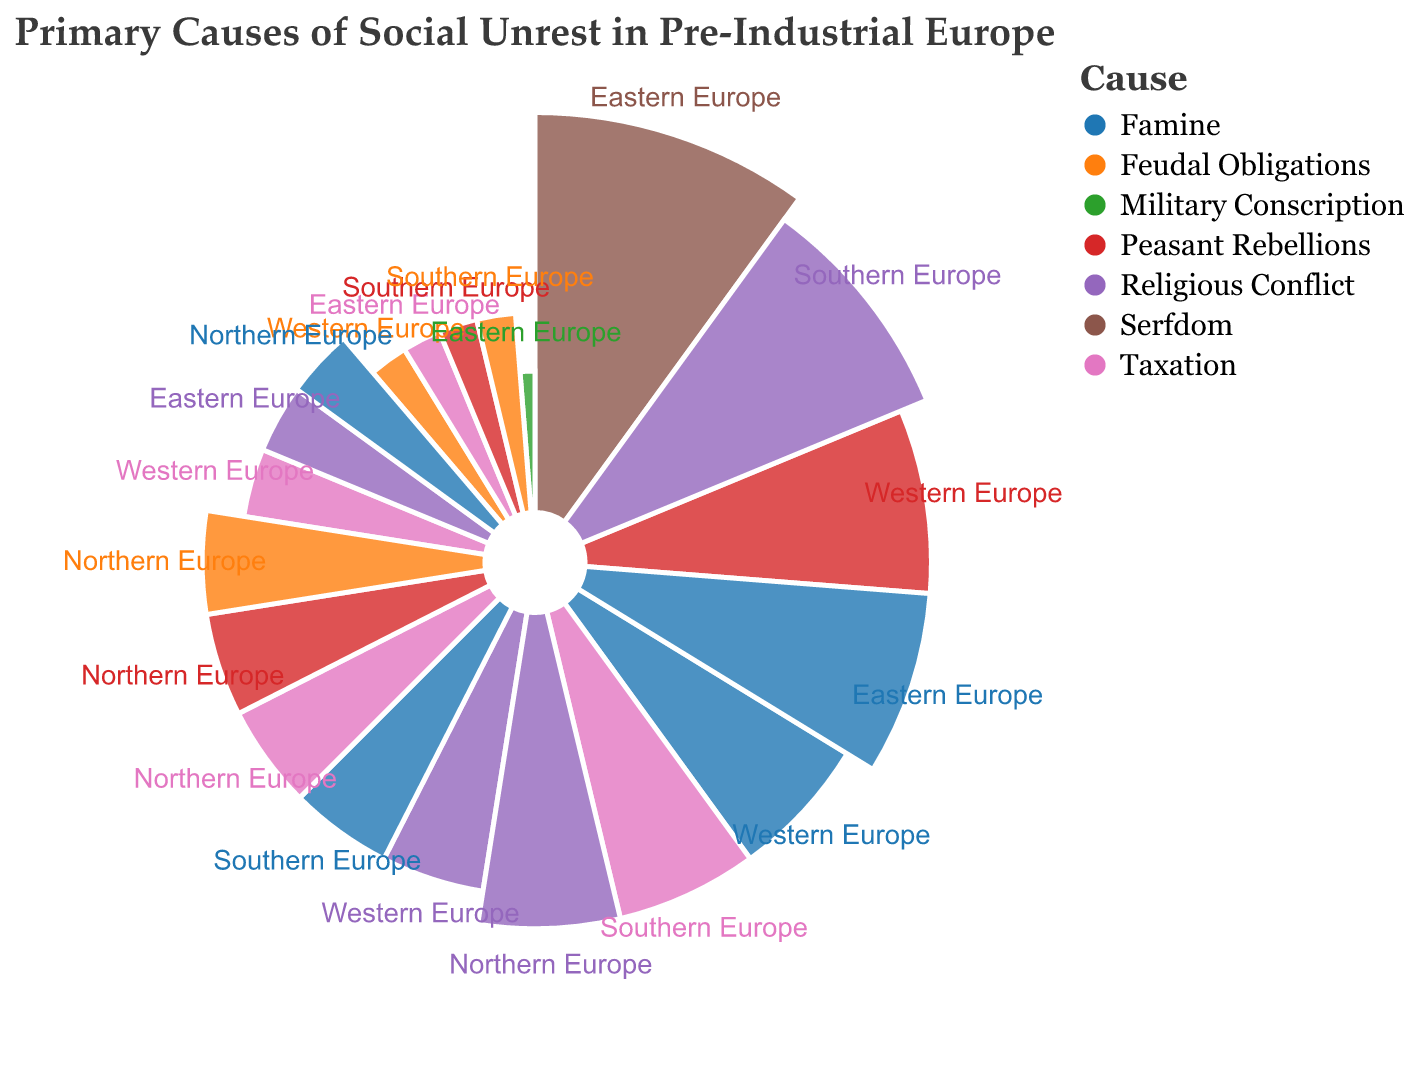What is the primary cause of social unrest in Eastern Europe? The largest segment in Eastern Europe is Serfdom, occupying 40% of the causes of social unrest.
Answer: Serfdom Which region attributes the highest percentage to Religious Conflict? Southern Europe attributes 35% to Religious Conflict, which is the highest percentage among the regions compared to 20% in Western Europe, 25% in Northern Europe, and 15% in Eastern Europe.
Answer: Southern Europe What is the combined percentage of Famine and Peasant Rebellions in Western Europe? In Western Europe, Famine accounts for 25% and Peasant Rebellions for 30%. The combined percentage is 25% + 30% = 55%.
Answer: 55% How does the percentage of social unrest caused by Taxation in Southern Europe compare to Northern Europe? In Southern Europe, Taxation accounts for 25%, whereas in Northern Europe it accounts for 20%. Southern Europe has a higher percentage of unrest caused by Taxation by 5%.
Answer: Southern Europe by 5% Which region has the least concern with Military Conscription as a cause of social unrest? Only Eastern Europe has Military Conscription listed, with a 5% contribution, making it the least concerned region overall.
Answer: Eastern Europe What is the total percentage of societal unrest attributed to Feudal Obligations in Northern and Southern Europe combined? Northern Europe and Southern Europe both attribute 20% and 10% respectively to Feudal Obligations. The combined percentage is 20% + 10% = 30%.
Answer: 30% Which cause of social unrest appears uniquely in Eastern Europe but not in other regions? The cause Serfdom appears only in Eastern Europe with a percentage of 40%, and it is not listed in any other regions.
Answer: Serfdom Calculate the average percentage for Religious Conflict across all regions. The percentages for Religious Conflict are 20% (Western Europe), 15% (Eastern Europe), 35% (Southern Europe), and 25% (Northern Europe). The average is (20 + 15 + 35 + 25) / 4 = 95 / 4 = 23.75%.
Answer: 23.75% What is the second most common cause of social unrest in Northern Europe? The percentages for Northern Europe are Famine (15%), Taxation (20%), Religious Conflict (25%), Peasant Rebellions (20%), and Feudal Obligations (20%). The second most common cause, after Religious Conflict (25%), is a tie between Taxation, Peasant Rebellions, and Feudal Obligations, each at 20%.
Answer: Taxation, Peasant Rebellions, Feudal Obligations In which region does Famine cause the most social unrest and what is the percentage? The region with the highest percentage for Famine is Eastern Europe, where it contributes 30% to social unrest. Other regions have lower percentages: Western Europe (25%), Southern Europe (20%), and Northern Europe (15%).
Answer: Eastern Europe, 30% 